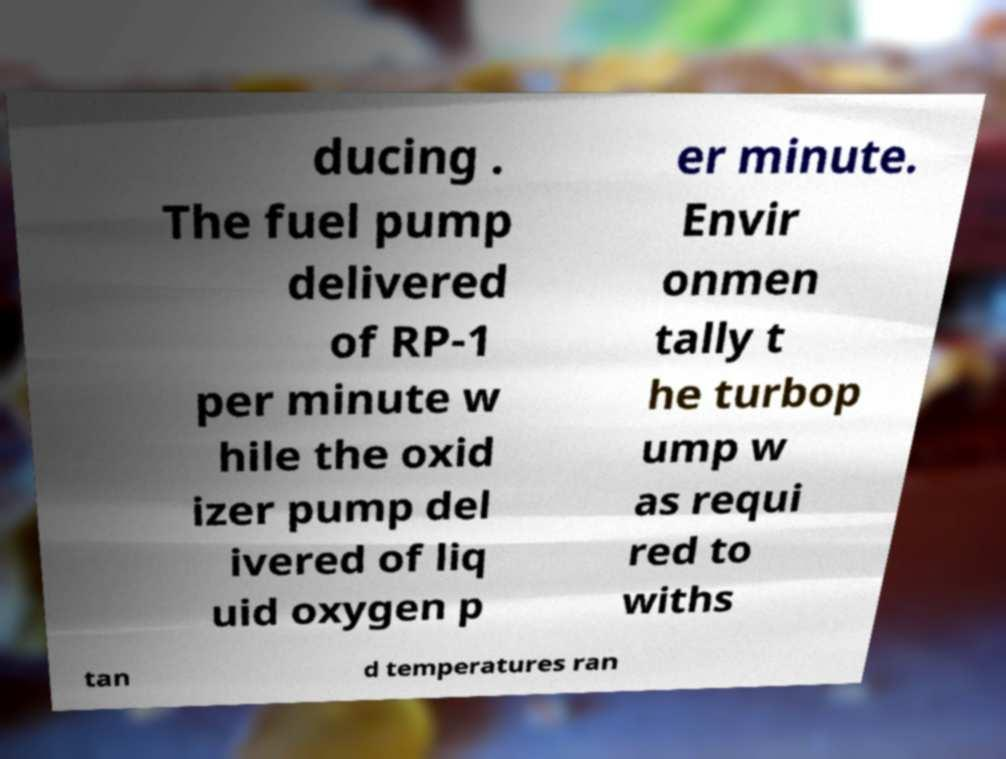Can you read and provide the text displayed in the image?This photo seems to have some interesting text. Can you extract and type it out for me? ducing . The fuel pump delivered of RP-1 per minute w hile the oxid izer pump del ivered of liq uid oxygen p er minute. Envir onmen tally t he turbop ump w as requi red to withs tan d temperatures ran 